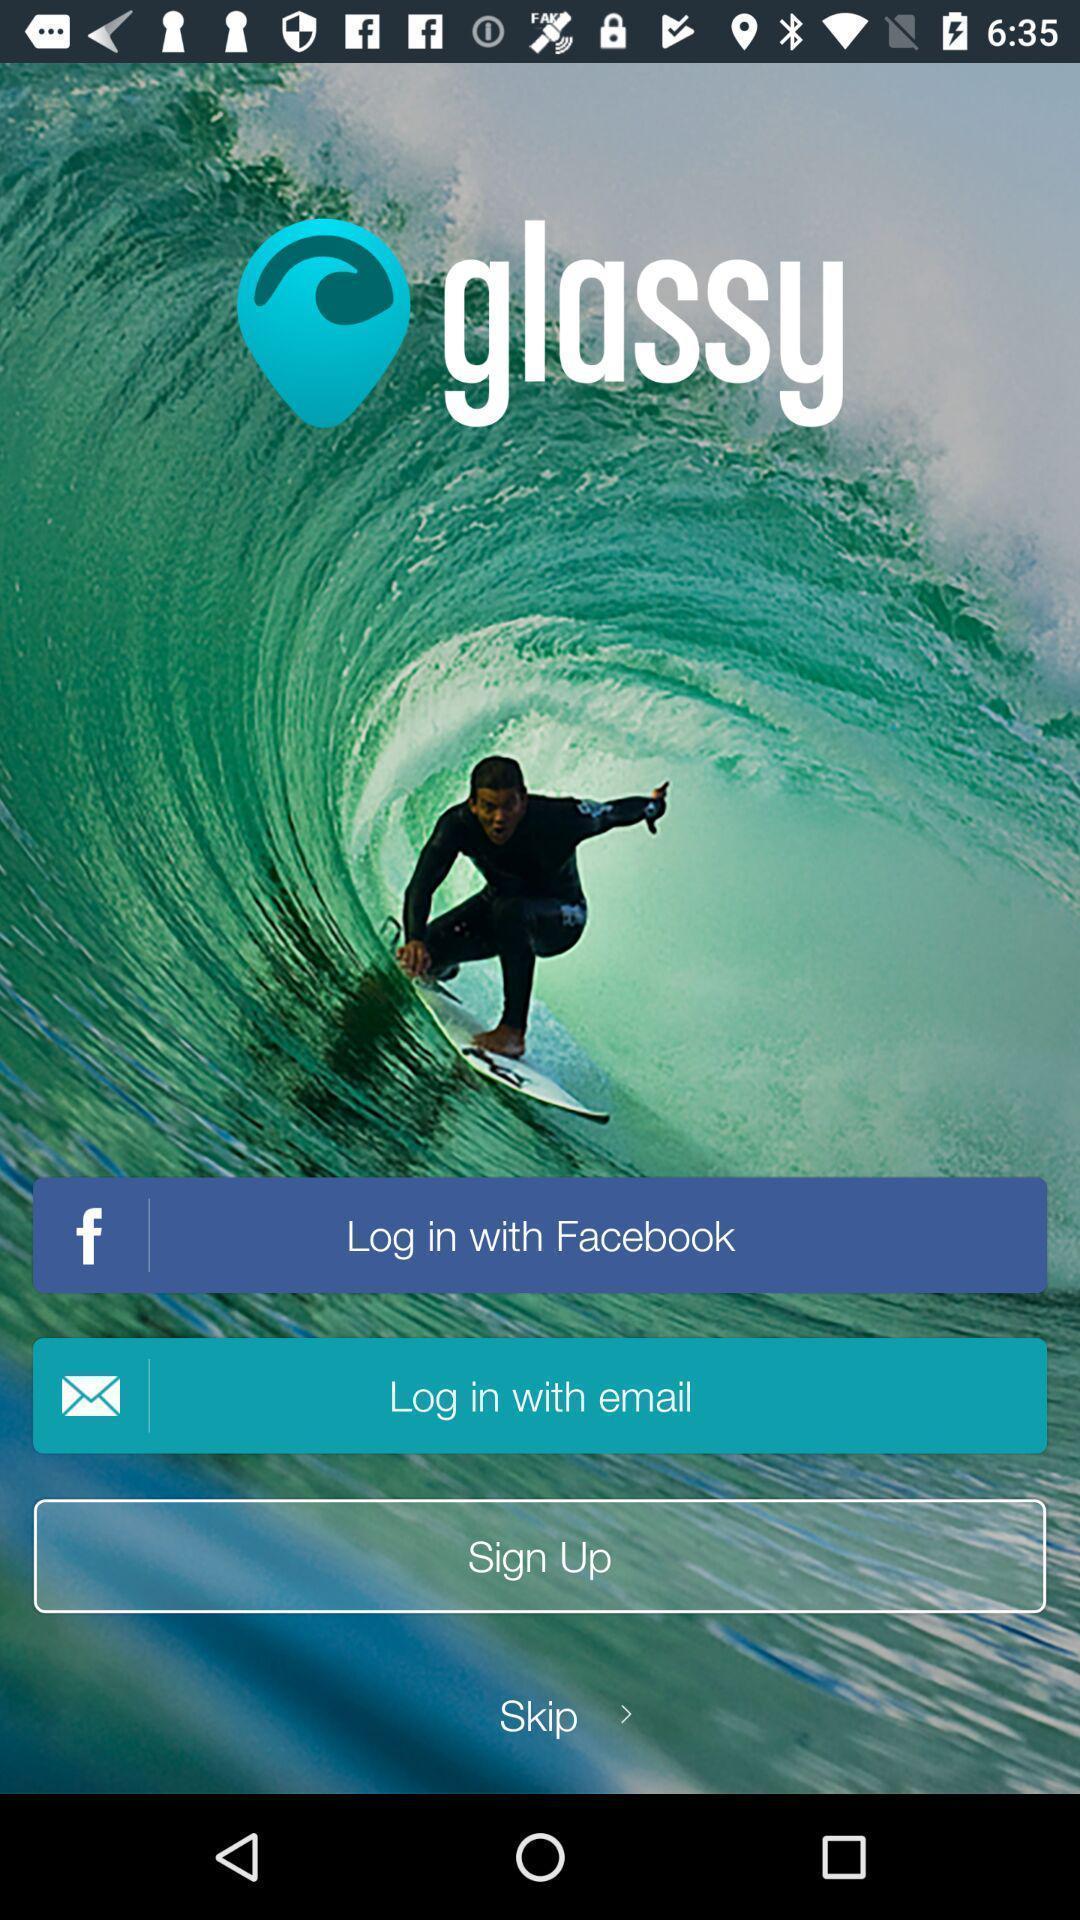Provide a textual representation of this image. Welcome page of sports application. 